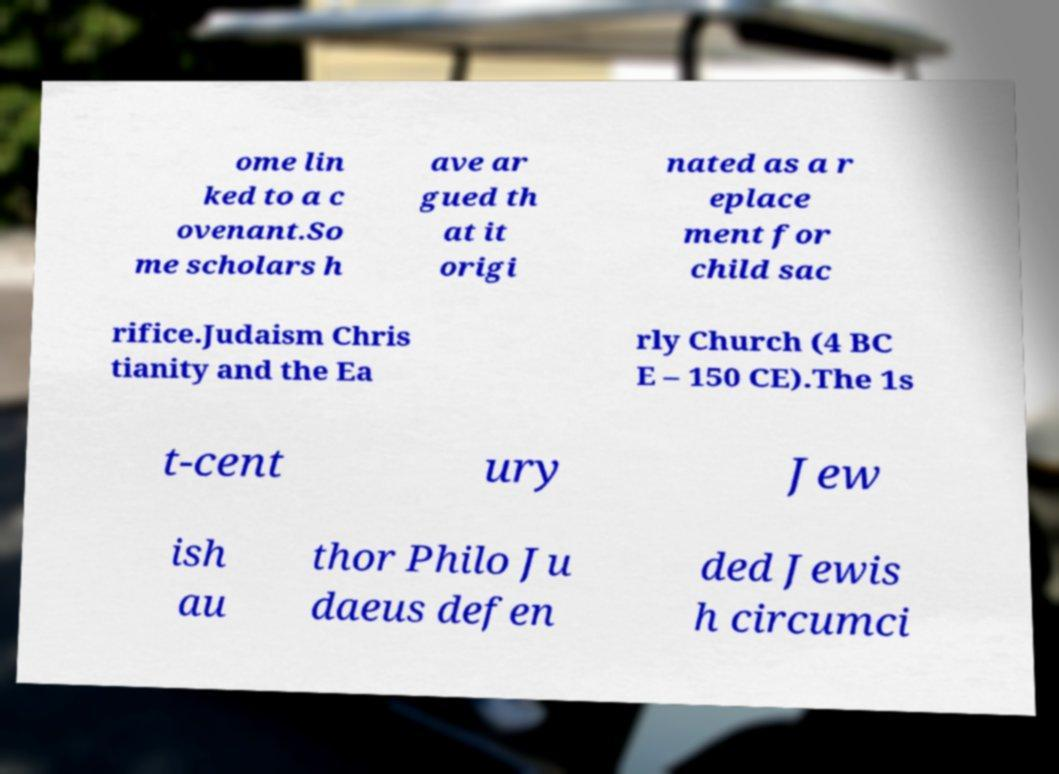Please read and relay the text visible in this image. What does it say? ome lin ked to a c ovenant.So me scholars h ave ar gued th at it origi nated as a r eplace ment for child sac rifice.Judaism Chris tianity and the Ea rly Church (4 BC E – 150 CE).The 1s t-cent ury Jew ish au thor Philo Ju daeus defen ded Jewis h circumci 